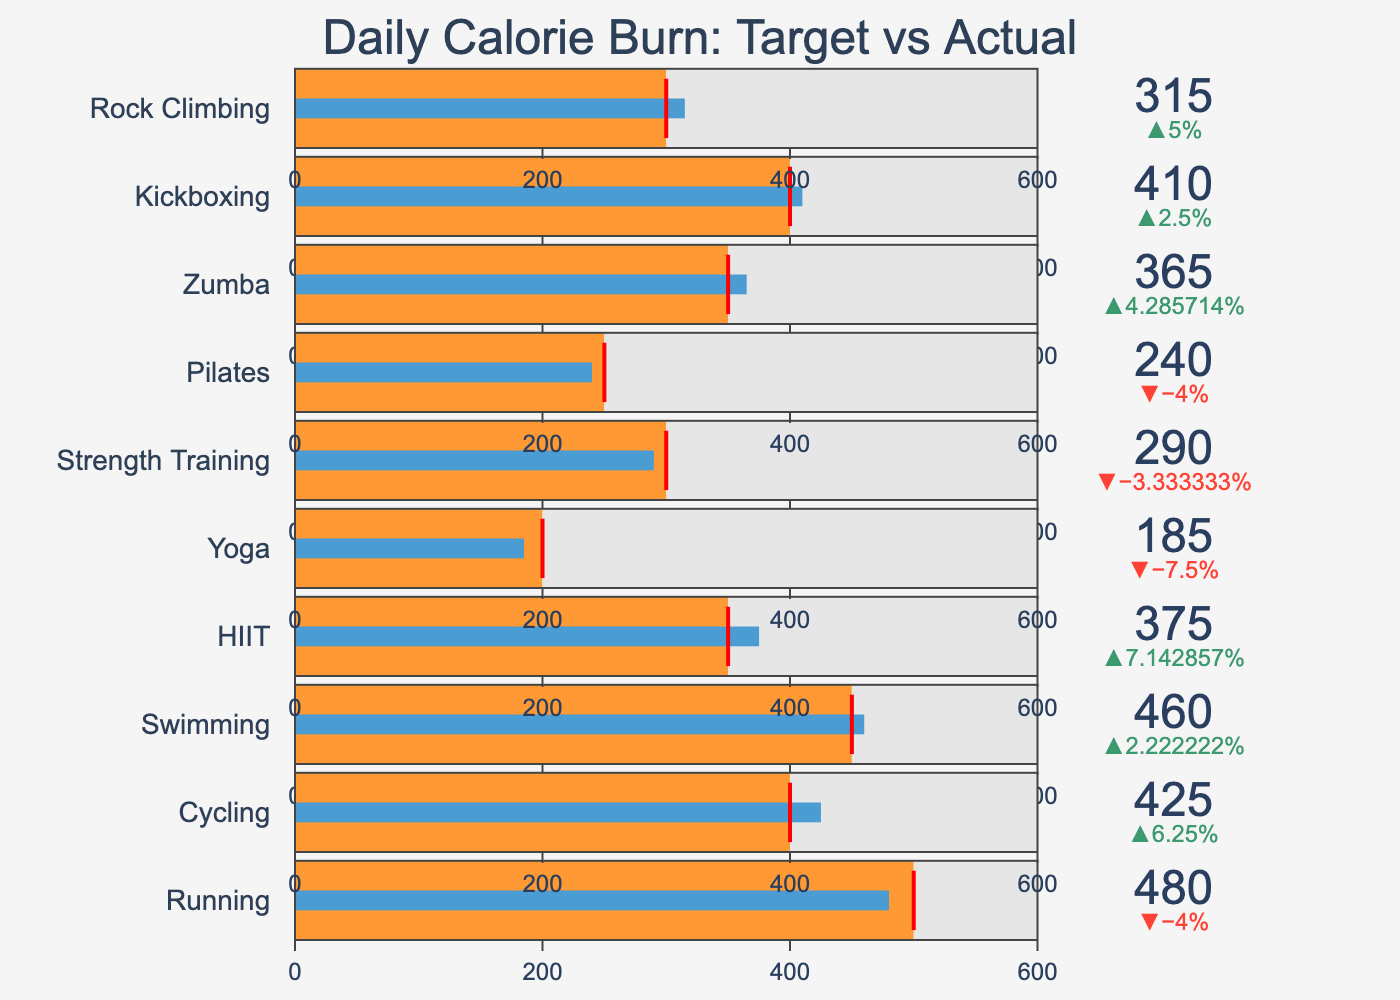What's the title of the bullet chart? The title is usually displayed prominently at the top of the chart. By looking at the figure, the title reads "Daily Calorie Burn: Target vs Actual".
Answer: Daily Calorie Burn: Target vs Actual Which exercise type has the closest actual calories burned to its target? The actual calories burned for the exercise "Running" is 480, which is very close to its target of 500 calories.
Answer: Running How many exercise types have actual calories burned exceeding their targets? By visually checking the bullet chart, which shows the actual values (blue bar) crossing the target threshold (red line), we find that Cycling, Swimming, HIIT, Zumba, Kickboxing, and Rock Climbing exceed their targets.
Answer: 6 What is the largest difference between the target and actual calories burned among all exercise types? By inspecting each bar's length and comparing to the target line, we find that Cycling has a target of 400 calories and an actual value of 425 calories, resulting in a difference of 25 calories, which appears to be the largest difference.
Answer: 25 calories Which exercise type has the lowest actual calorie burn, and what is that value? By scanning the chart from top to bottom, Yoga has the lowest actual calorie burn, which is 185 calories.
Answer: Yoga, 185 calories What is the average target calorie burn across all exercise types? To calculate this, sum all target calories and divide by the number of exercise types: (500 + 400 + 450 + 350 + 200 + 300 + 250 + 350 + 400 + 300) / 10 = 3500 / 10 = 350.
Answer: 350 For Rock Climbing, did the actual calories burned exceed the target? For Rock Climbing, the actual calories burned are 315, while the target is 300. The actual exceeds the target.
Answer: Yes Compare the actual calories burned for HIIT and Strength Training. Which one burned more? By comparing the actual numbers on the indicators, HIIT has 375 actual calories burned, while Strength Training has 290. Thus, HIIT burned more calories.
Answer: HIIT What is the median of target calories across all exercise types? To find the median, first sort the target calories: [200, 250, 300, 300, 350, 350, 400, 400, 450, 500]. The median is the average of the 5th and 6th values: (350 + 350) / 2 = 350.
Answer: 350 